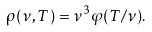<formula> <loc_0><loc_0><loc_500><loc_500>\rho ( \nu , T ) = \nu ^ { 3 } \varphi ( T / \nu ) .</formula> 